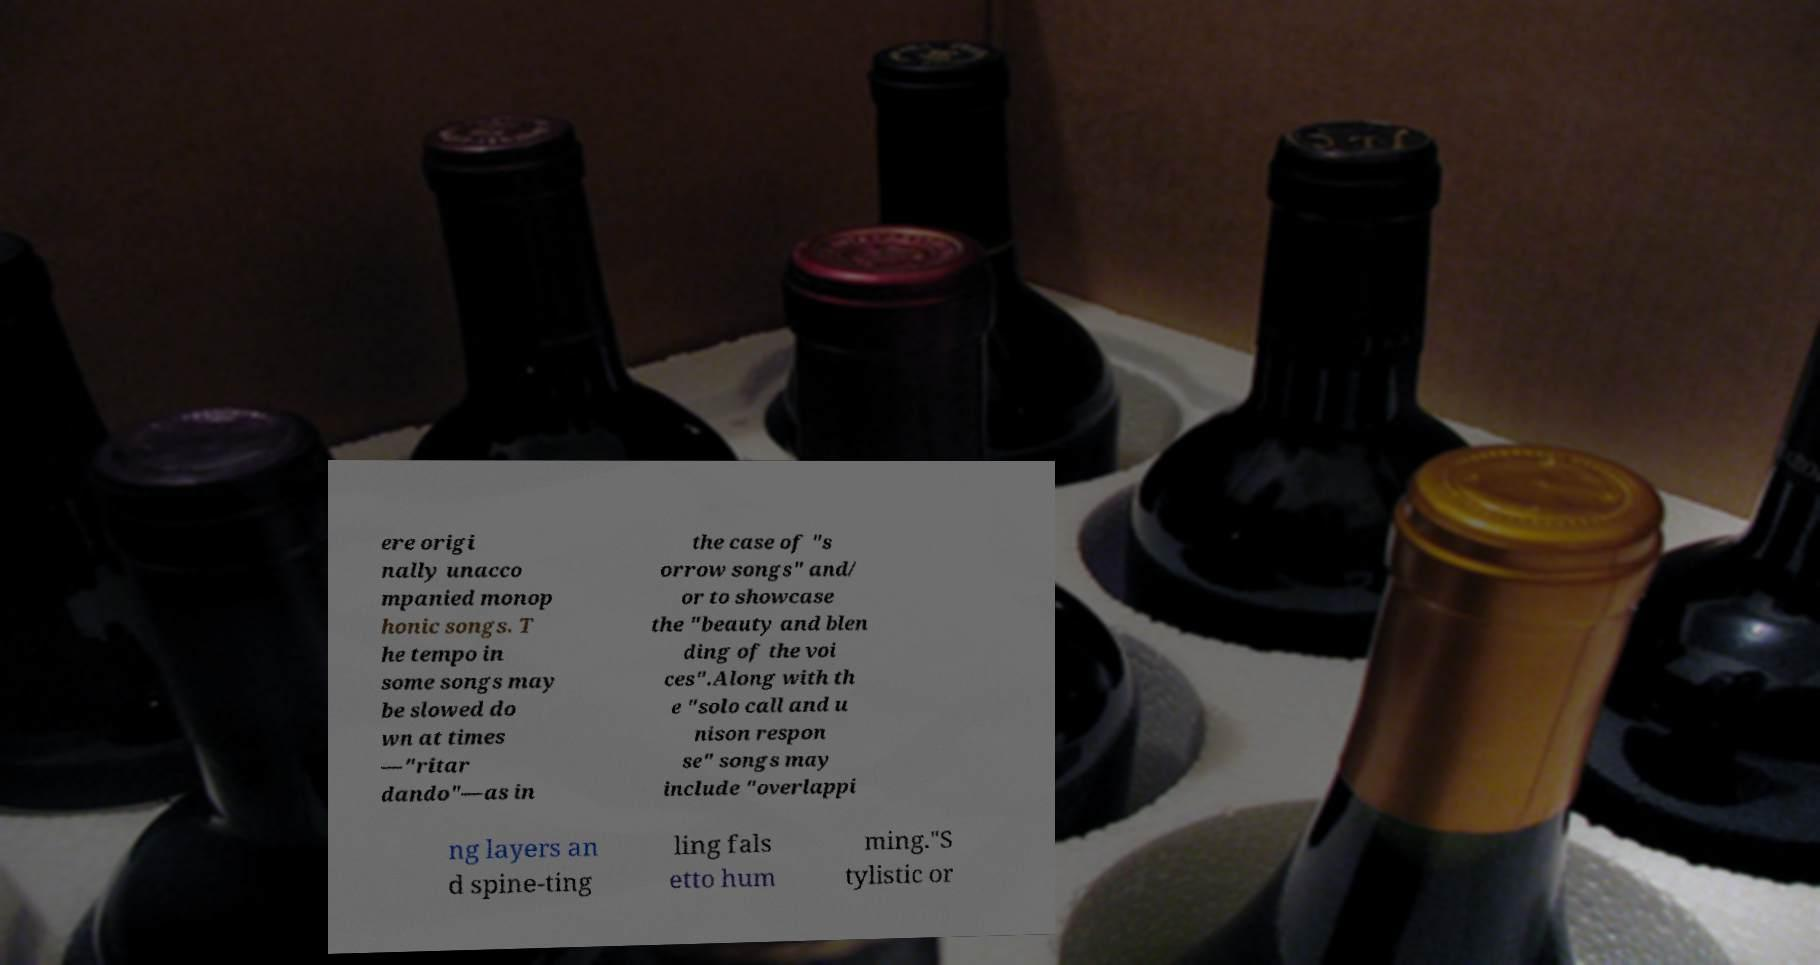Please read and relay the text visible in this image. What does it say? ere origi nally unacco mpanied monop honic songs. T he tempo in some songs may be slowed do wn at times —"ritar dando"—as in the case of "s orrow songs" and/ or to showcase the "beauty and blen ding of the voi ces".Along with th e "solo call and u nison respon se" songs may include "overlappi ng layers an d spine-ting ling fals etto hum ming."S tylistic or 